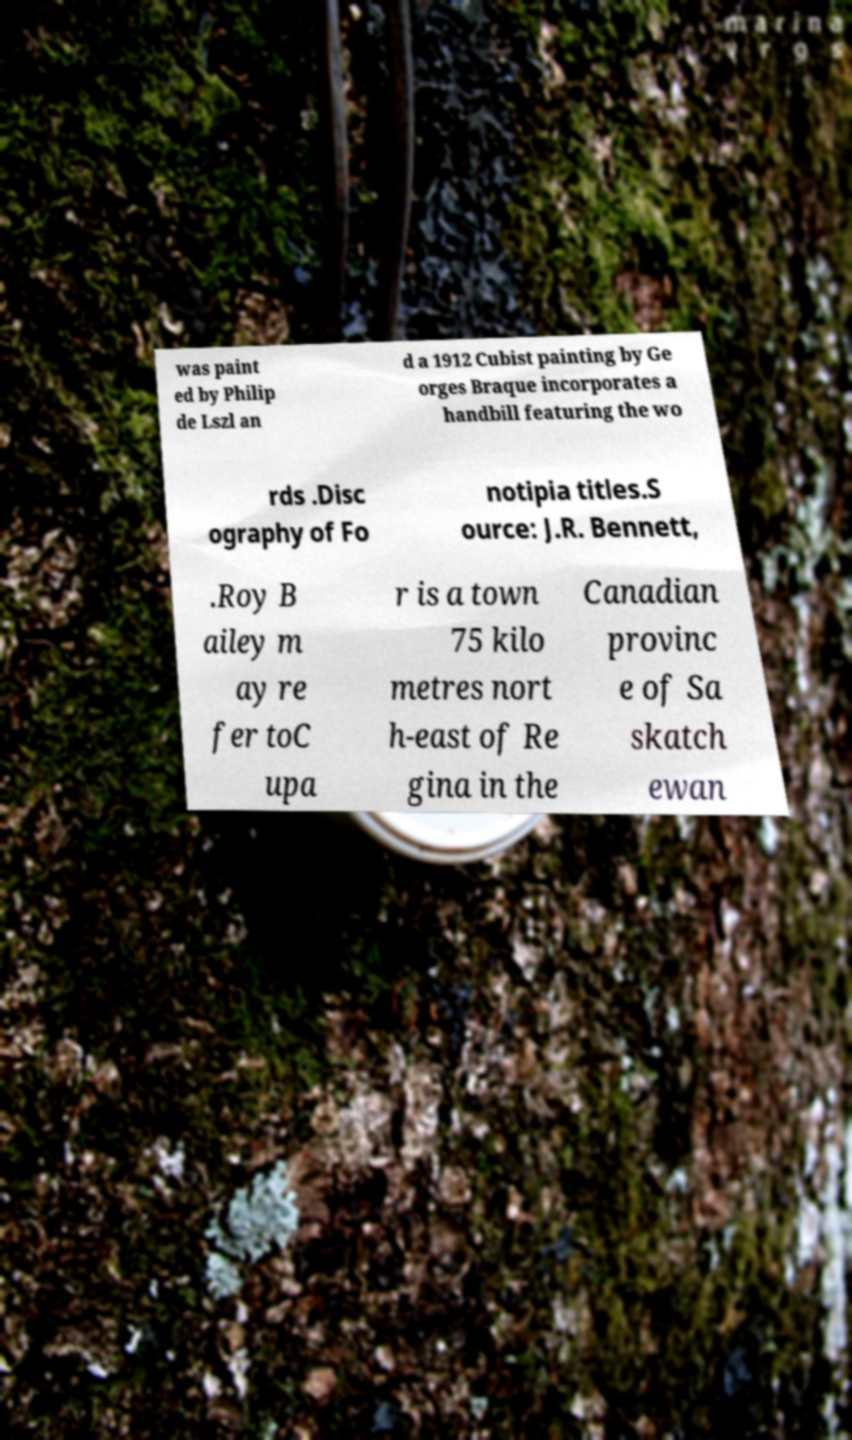Please read and relay the text visible in this image. What does it say? was paint ed by Philip de Lszl an d a 1912 Cubist painting by Ge orges Braque incorporates a handbill featuring the wo rds .Disc ography of Fo notipia titles.S ource: J.R. Bennett, .Roy B ailey m ay re fer toC upa r is a town 75 kilo metres nort h-east of Re gina in the Canadian provinc e of Sa skatch ewan 